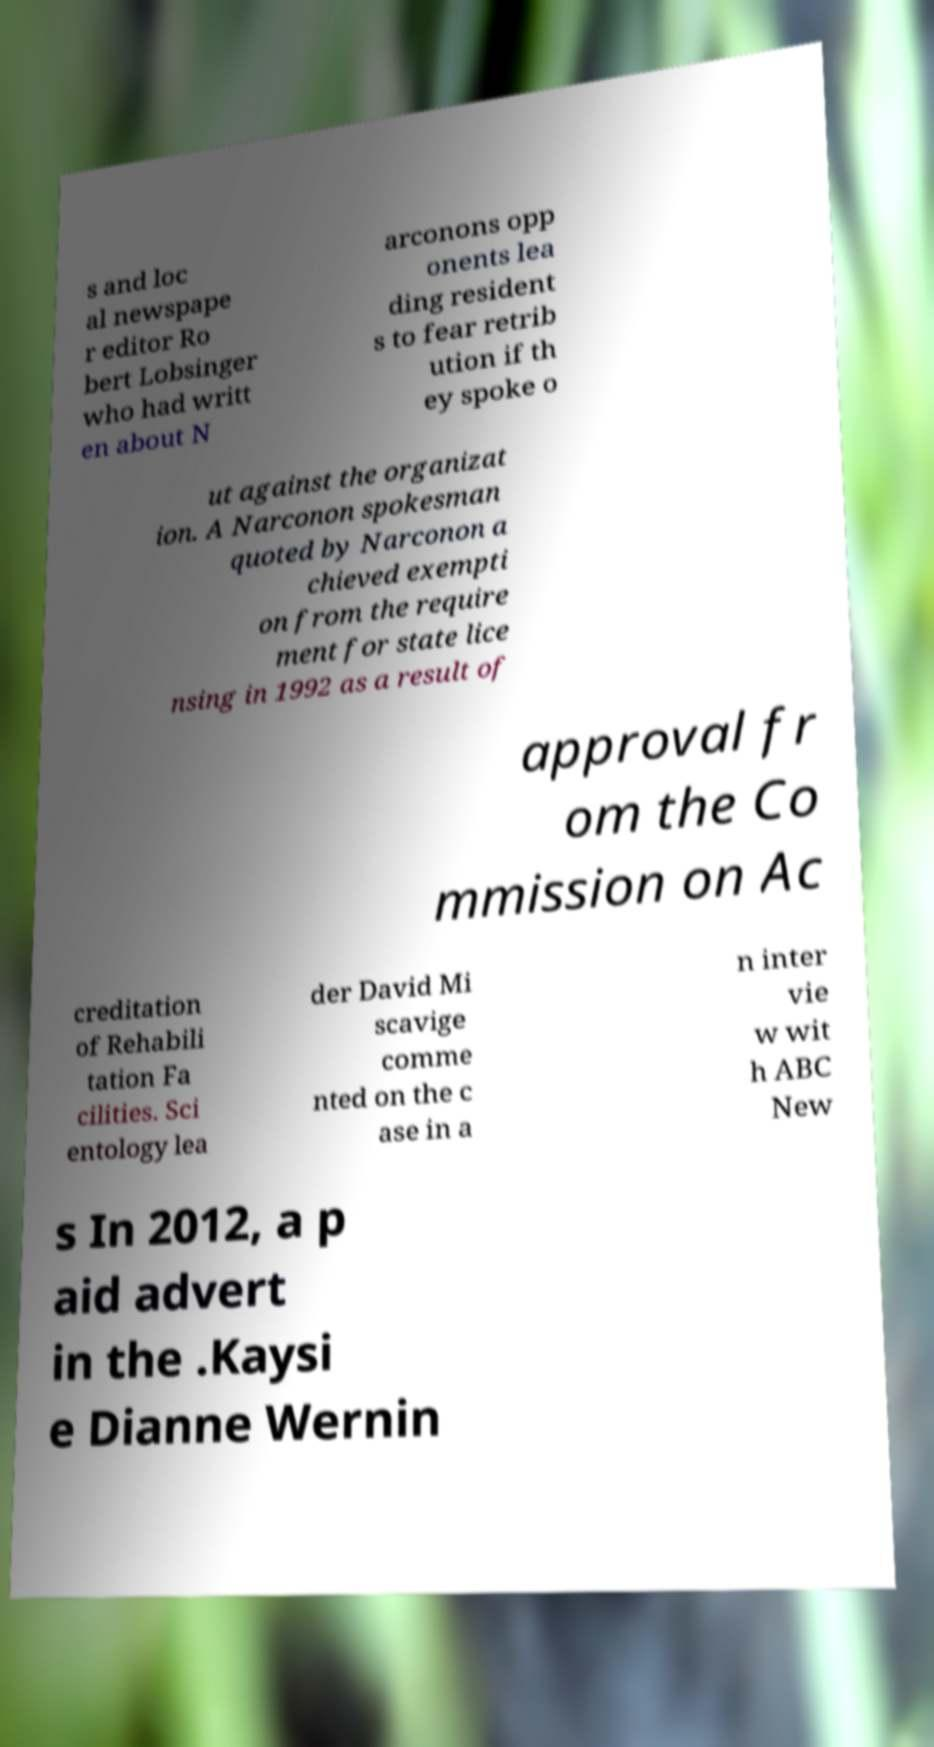Could you extract and type out the text from this image? s and loc al newspape r editor Ro bert Lobsinger who had writt en about N arconons opp onents lea ding resident s to fear retrib ution if th ey spoke o ut against the organizat ion. A Narconon spokesman quoted by Narconon a chieved exempti on from the require ment for state lice nsing in 1992 as a result of approval fr om the Co mmission on Ac creditation of Rehabili tation Fa cilities. Sci entology lea der David Mi scavige comme nted on the c ase in a n inter vie w wit h ABC New s In 2012, a p aid advert in the .Kaysi e Dianne Wernin 